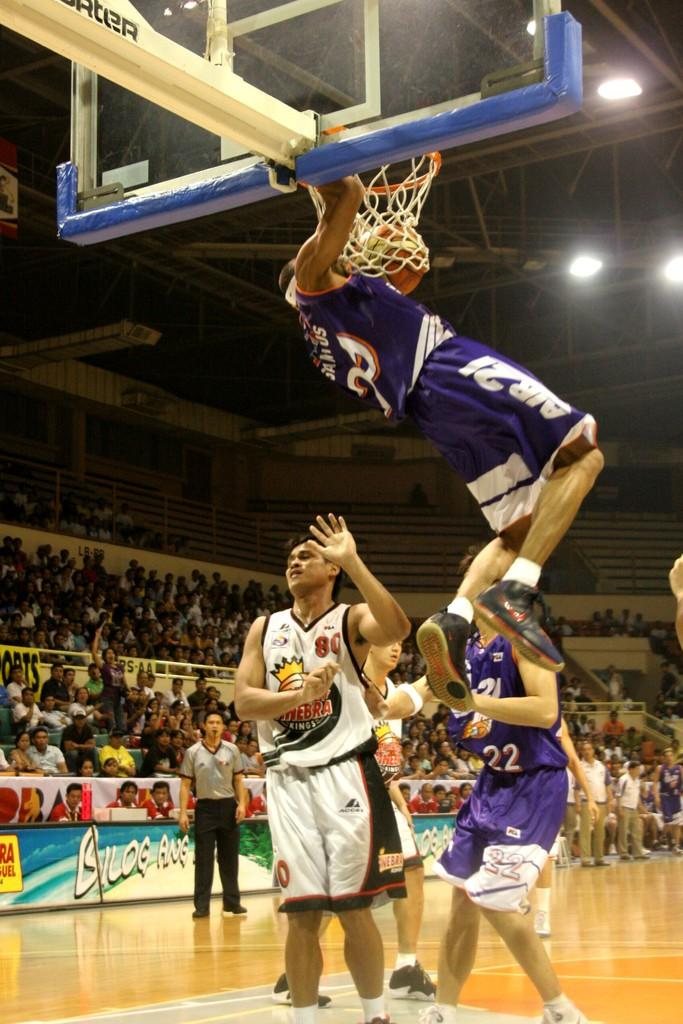<image>
Relay a brief, clear account of the picture shown. Number 80 for the Kings just got dunked on. 